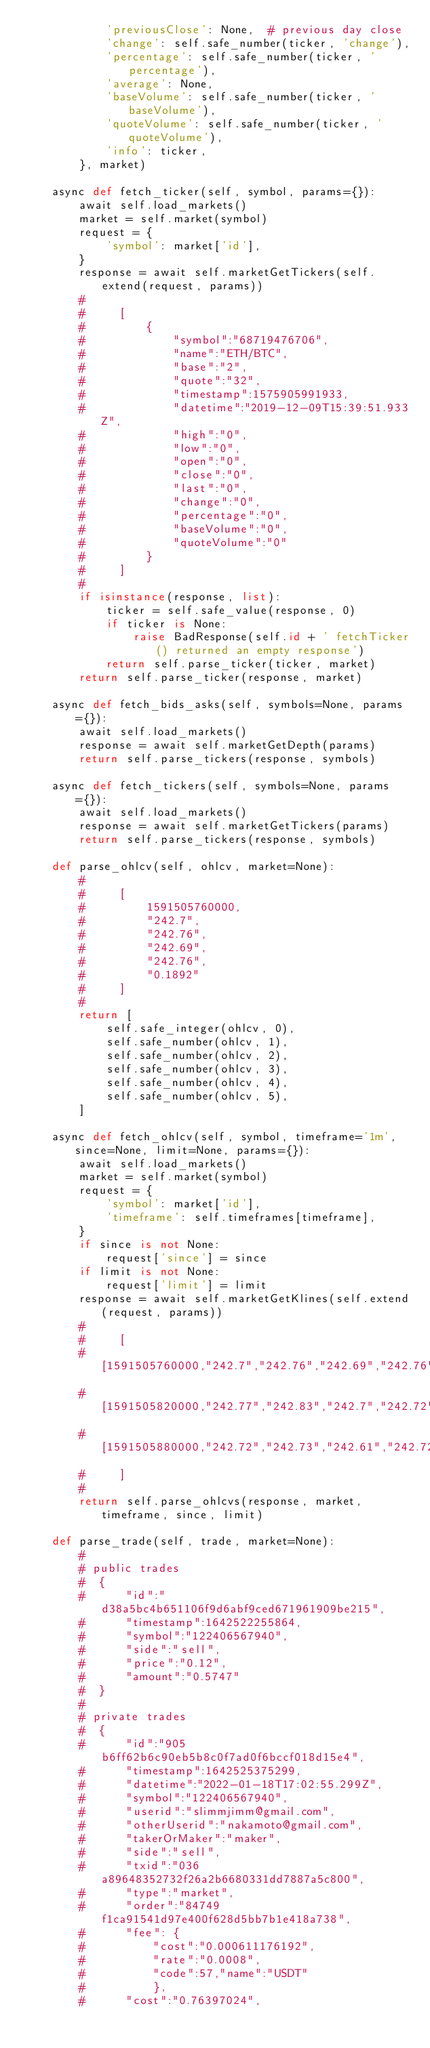Convert code to text. <code><loc_0><loc_0><loc_500><loc_500><_Python_>            'previousClose': None,  # previous day close
            'change': self.safe_number(ticker, 'change'),
            'percentage': self.safe_number(ticker, 'percentage'),
            'average': None,
            'baseVolume': self.safe_number(ticker, 'baseVolume'),
            'quoteVolume': self.safe_number(ticker, 'quoteVolume'),
            'info': ticker,
        }, market)

    async def fetch_ticker(self, symbol, params={}):
        await self.load_markets()
        market = self.market(symbol)
        request = {
            'symbol': market['id'],
        }
        response = await self.marketGetTickers(self.extend(request, params))
        #
        #     [
        #         {
        #             "symbol":"68719476706",
        #             "name":"ETH/BTC",
        #             "base":"2",
        #             "quote":"32",
        #             "timestamp":1575905991933,
        #             "datetime":"2019-12-09T15:39:51.933Z",
        #             "high":"0",
        #             "low":"0",
        #             "open":"0",
        #             "close":"0",
        #             "last":"0",
        #             "change":"0",
        #             "percentage":"0",
        #             "baseVolume":"0",
        #             "quoteVolume":"0"
        #         }
        #     ]
        #
        if isinstance(response, list):
            ticker = self.safe_value(response, 0)
            if ticker is None:
                raise BadResponse(self.id + ' fetchTicker() returned an empty response')
            return self.parse_ticker(ticker, market)
        return self.parse_ticker(response, market)

    async def fetch_bids_asks(self, symbols=None, params={}):
        await self.load_markets()
        response = await self.marketGetDepth(params)
        return self.parse_tickers(response, symbols)

    async def fetch_tickers(self, symbols=None, params={}):
        await self.load_markets()
        response = await self.marketGetTickers(params)
        return self.parse_tickers(response, symbols)

    def parse_ohlcv(self, ohlcv, market=None):
        #
        #     [
        #         1591505760000,
        #         "242.7",
        #         "242.76",
        #         "242.69",
        #         "242.76",
        #         "0.1892"
        #     ]
        #
        return [
            self.safe_integer(ohlcv, 0),
            self.safe_number(ohlcv, 1),
            self.safe_number(ohlcv, 2),
            self.safe_number(ohlcv, 3),
            self.safe_number(ohlcv, 4),
            self.safe_number(ohlcv, 5),
        ]

    async def fetch_ohlcv(self, symbol, timeframe='1m', since=None, limit=None, params={}):
        await self.load_markets()
        market = self.market(symbol)
        request = {
            'symbol': market['id'],
            'timeframe': self.timeframes[timeframe],
        }
        if since is not None:
            request['since'] = since
        if limit is not None:
            request['limit'] = limit
        response = await self.marketGetKlines(self.extend(request, params))
        #
        #     [
        #         [1591505760000,"242.7","242.76","242.69","242.76","0.1892"],
        #         [1591505820000,"242.77","242.83","242.7","242.72","0.6378"],
        #         [1591505880000,"242.72","242.73","242.61","242.72","0.4141"],
        #     ]
        #
        return self.parse_ohlcvs(response, market, timeframe, since, limit)

    def parse_trade(self, trade, market=None):
        #
        # public trades
        #  {
        #      "id":"d38a5bc4b651106f9d6abf9ced671961909be215",
        #      "timestamp":1642522255864,
        #      "symbol":"122406567940",
        #      "side":"sell",
        #      "price":"0.12",
        #      "amount":"0.5747"
        #  }
        #
        # private trades
        #  {
        #      "id":"905b6ff62b6c90eb5b8c0f7ad0f6bccf018d15e4",
        #      "timestamp":1642525375299,
        #      "datetime":"2022-01-18T17:02:55.299Z",
        #      "symbol":"122406567940",
        #      "userid":"slimmjimm@gmail.com",
        #      "otherUserid":"nakamoto@gmail.com",
        #      "takerOrMaker":"maker",
        #      "side":"sell",
        #      "txid":"036a89648352732f26a2b6680331dd7887a5c800",
        #      "type":"market",
        #      "order":"84749f1ca91541d97e400f628d5bb7b1e418a738",
        #      "fee": {
        #          "cost":"0.000611176192",
        #          "rate":"0.0008",
        #          "code":57,"name":"USDT"
        #          },
        #      "cost":"0.76397024",</code> 